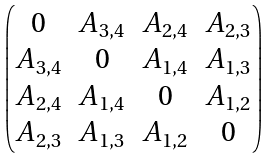<formula> <loc_0><loc_0><loc_500><loc_500>\begin{pmatrix} 0 & A _ { 3 , 4 } & A _ { 2 , 4 } & A _ { 2 , 3 } \\ A _ { 3 , 4 } & 0 & A _ { 1 , 4 } & A _ { 1 , 3 } \\ A _ { 2 , 4 } & A _ { 1 , 4 } & 0 & A _ { 1 , 2 } \\ A _ { 2 , 3 } & A _ { 1 , 3 } & A _ { 1 , 2 } & 0 \end{pmatrix}</formula> 